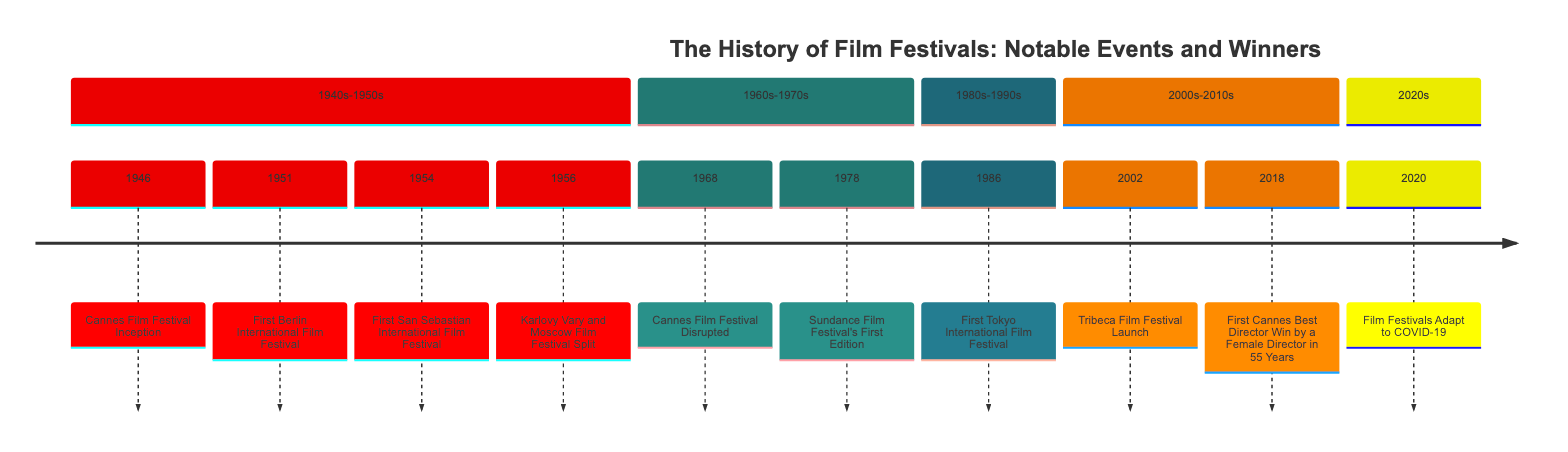What year did the Cannes Film Festival start? According to the timeline, the Cannes Film Festival was inaugurated in 1946. You can find this information at the beginning of the timeline, in the section labeled "1940s-1950s."
Answer: 1946 What event happened in 2018? In 2018, the timeline states that Alice Rohrwacher won Best Director at Cannes for "Happy as Lazzaro." This information can be found in the section for the 2000s-2010s.
Answer: First Cannes Best Director Win by a Female Director in 55 Years How many festivals are documented in the 1960s-1970s section? In the section labeled "1960s-1970s," there are two events listed: one for the Cannes Film Festival in 1968 and one for the Sundance Film Festival in 1978. Therefore, there are two festivals documented in this section.
Answer: 2 What was significant about the Cannes Film Festival in 1968? The 1968 event in the timeline indicates that the Cannes Film Festival was disrupted due to the May 1968 protests in France and was ultimately canceled. This reflects the socio-political context of that time.
Answer: Disrupted due to May 1968 protests Which festival is associated with Robert De Niro? The timeline mentions the Tribeca Film Festival, which was founded by Robert De Niro along with Jane Rosenthal and Craig Hatkoff. This information appears in the section for the 2000s-2010s, specifically for the year 2002.
Answer: Tribeca Film Festival What adaptation did film festivals make in 2020? The timeline states that major film festivals adapted to COVID-19 by incorporating virtual screenings and online components. This adaptation is noted as a significant change in the landscape of film festivals during that year.
Answer: Incorporating virtual screenings and online components What was the purpose of establishing the Sundance Film Festival? The timeline describes that the Sundance Film Festival was established to be a venue for showcasing American independent films. The founding year, 1978, signifies its importance in supporting indie filmmakers.
Answer: Showcasing American independent films What year did the first San Sebastian International Film Festival take place? The timeline indicates that the first San Sebastian International Film Festival occurred in 1954. This year can be found in the 1940s-1950s section of the timeline.
Answer: 1954 